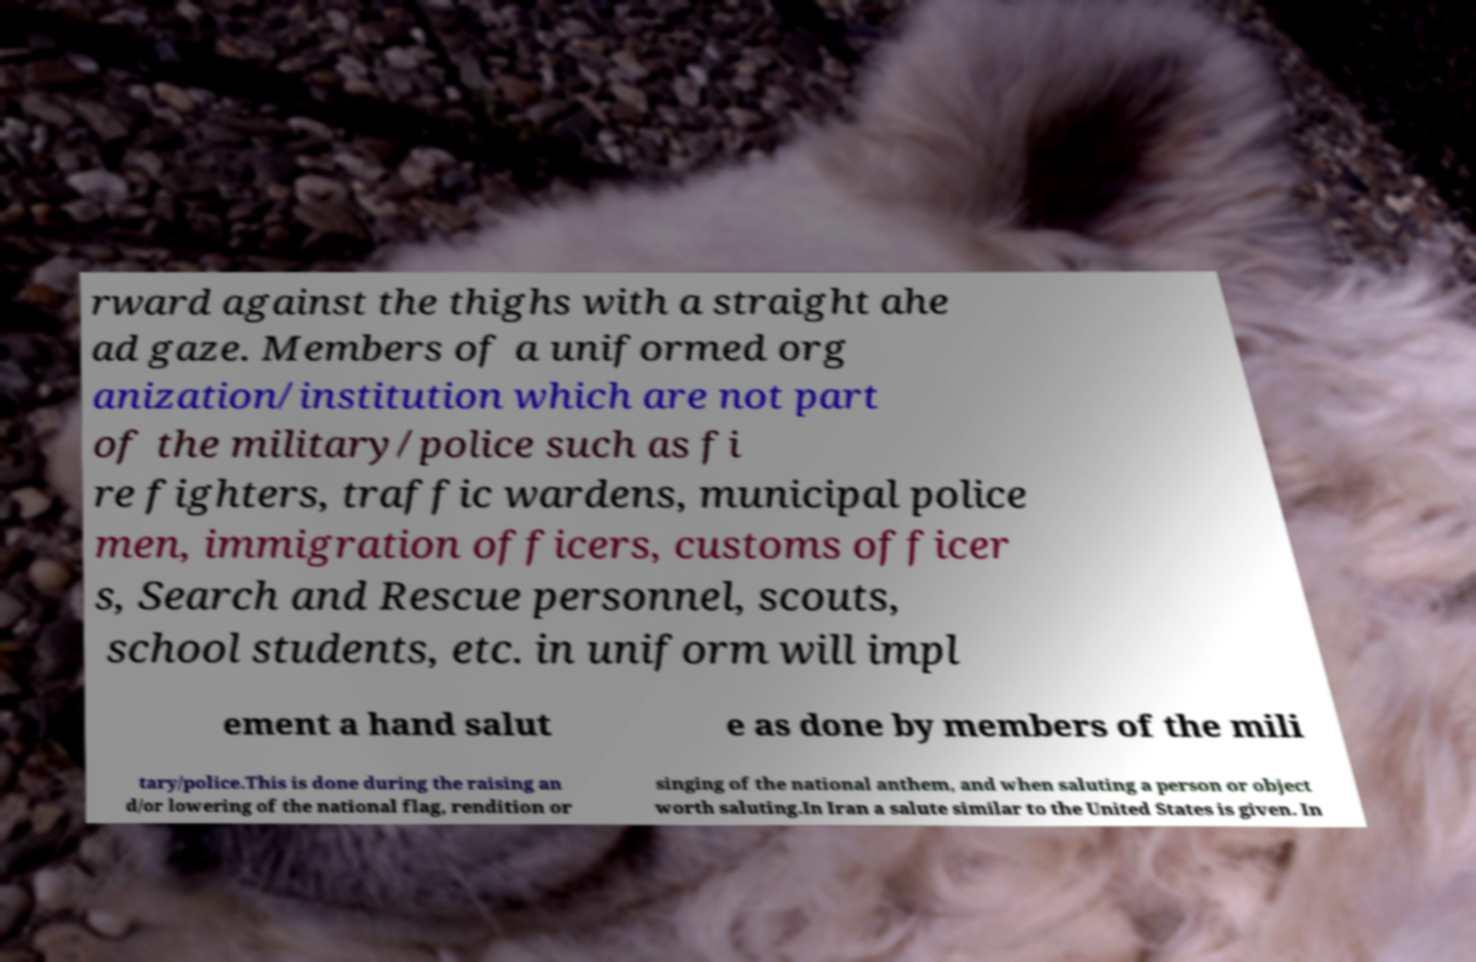Please read and relay the text visible in this image. What does it say? rward against the thighs with a straight ahe ad gaze. Members of a uniformed org anization/institution which are not part of the military/police such as fi re fighters, traffic wardens, municipal police men, immigration officers, customs officer s, Search and Rescue personnel, scouts, school students, etc. in uniform will impl ement a hand salut e as done by members of the mili tary/police.This is done during the raising an d/or lowering of the national flag, rendition or singing of the national anthem, and when saluting a person or object worth saluting.In Iran a salute similar to the United States is given. In 